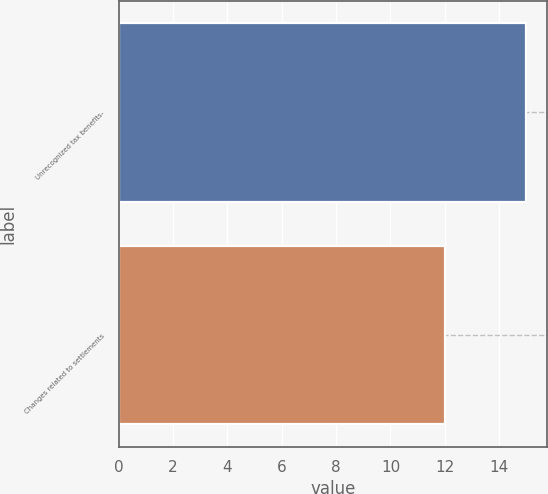<chart> <loc_0><loc_0><loc_500><loc_500><bar_chart><fcel>Unrecognized tax benefits-<fcel>Changes related to settlements<nl><fcel>15<fcel>12<nl></chart> 